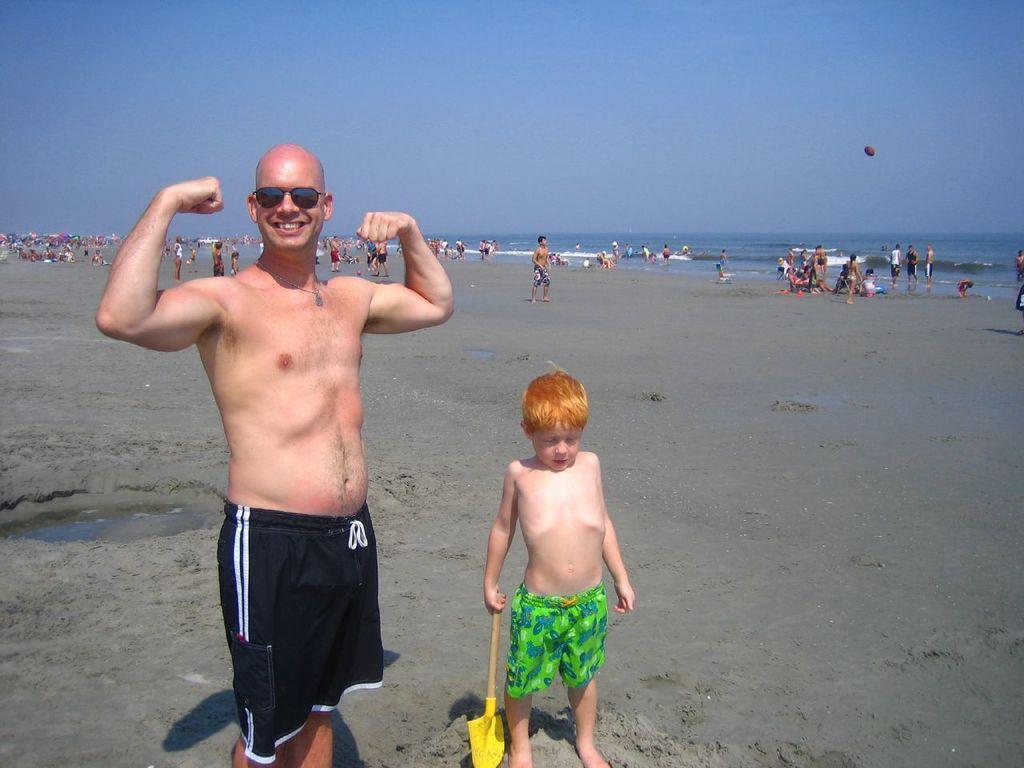Describe this image in one or two sentences. This picture is clicked outside the city. In the center there is a kid holding an object and standing on the ground. On the left there is a man standing on the ground. In the background we can see the group of people and a water body and there is an object in the air and we can see the sky. 